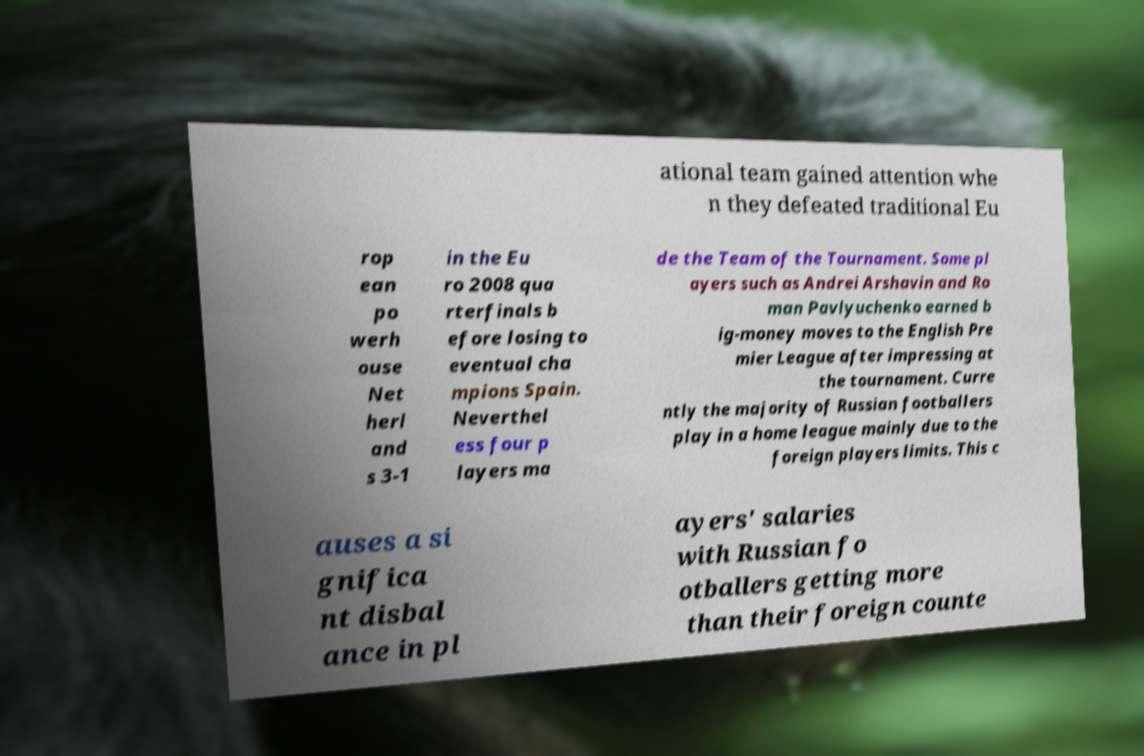What messages or text are displayed in this image? I need them in a readable, typed format. ational team gained attention whe n they defeated traditional Eu rop ean po werh ouse Net herl and s 3-1 in the Eu ro 2008 qua rterfinals b efore losing to eventual cha mpions Spain. Neverthel ess four p layers ma de the Team of the Tournament. Some pl ayers such as Andrei Arshavin and Ro man Pavlyuchenko earned b ig-money moves to the English Pre mier League after impressing at the tournament. Curre ntly the majority of Russian footballers play in a home league mainly due to the foreign players limits. This c auses a si gnifica nt disbal ance in pl ayers' salaries with Russian fo otballers getting more than their foreign counte 